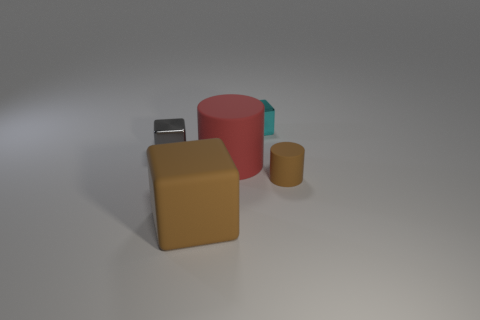What materials do the objects in the picture look like they're made from? The objects in the image appear to have different materials. The large red and tiny brown objects seem to be made from a matte plastic or rubber, while the silver cube has a reflective metallic finish, suggesting a metallic material. Lastly, the tan square has a diffuse, slightly rough texture that might resemble ceramics or a matte plastic. 